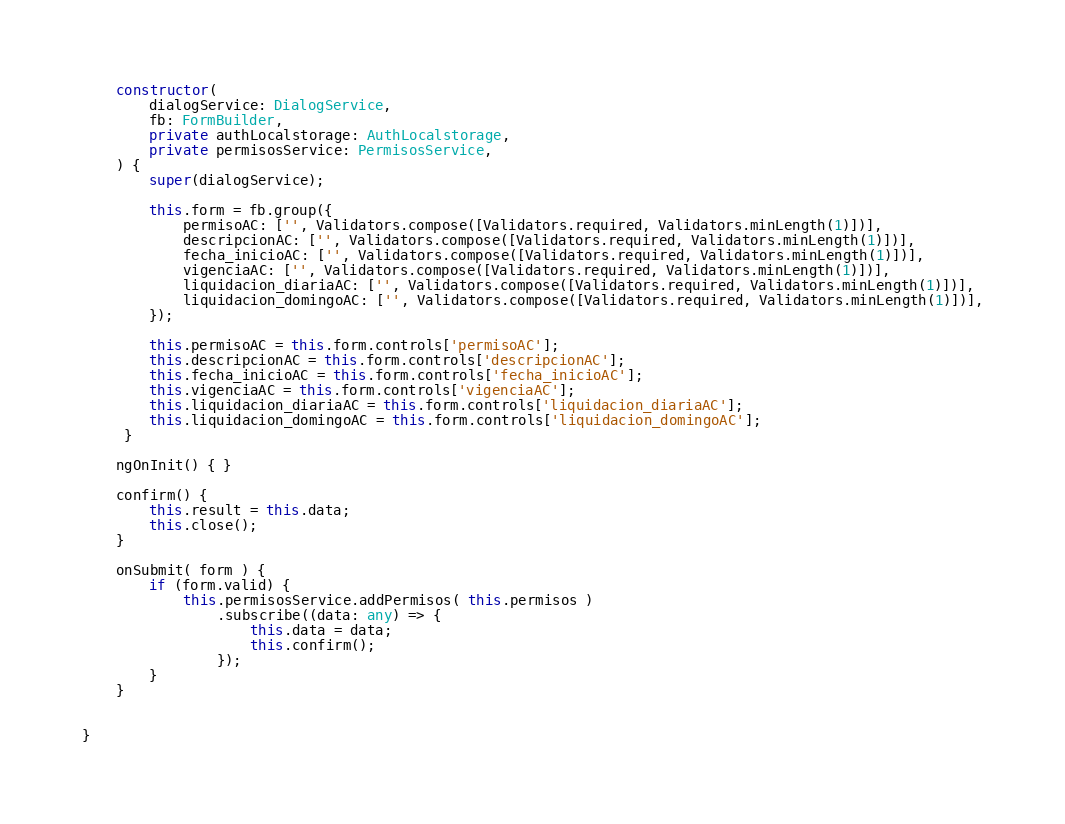Convert code to text. <code><loc_0><loc_0><loc_500><loc_500><_TypeScript_>

    constructor( 
        dialogService: DialogService,
        fb: FormBuilder,
        private authLocalstorage: AuthLocalstorage,
        private permisosService: PermisosService,
    ) {
        super(dialogService);

        this.form = fb.group({
            permisoAC: ['', Validators.compose([Validators.required, Validators.minLength(1)])],
            descripcionAC: ['', Validators.compose([Validators.required, Validators.minLength(1)])],
            fecha_inicioAC: ['', Validators.compose([Validators.required, Validators.minLength(1)])],
            vigenciaAC: ['', Validators.compose([Validators.required, Validators.minLength(1)])],
            liquidacion_diariaAC: ['', Validators.compose([Validators.required, Validators.minLength(1)])],
            liquidacion_domingoAC: ['', Validators.compose([Validators.required, Validators.minLength(1)])],
        });
                
        this.permisoAC = this.form.controls['permisoAC'];
        this.descripcionAC = this.form.controls['descripcionAC'];
        this.fecha_inicioAC = this.form.controls['fecha_inicioAC'];
        this.vigenciaAC = this.form.controls['vigenciaAC'];
        this.liquidacion_diariaAC = this.form.controls['liquidacion_diariaAC'];
        this.liquidacion_domingoAC = this.form.controls['liquidacion_domingoAC'];
     }

    ngOnInit() { }
    
    confirm() {
        this.result = this.data;
        this.close();
    }

    onSubmit( form ) {
        if (form.valid) {
            this.permisosService.addPermisos( this.permisos )
                .subscribe((data: any) => {                        
                    this.data = data;
                    this.confirm();
                });
        }
    }


}</code> 